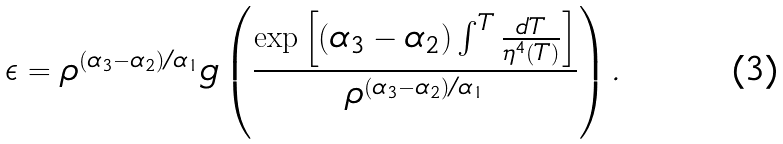<formula> <loc_0><loc_0><loc_500><loc_500>\epsilon = \rho ^ { ( \alpha _ { 3 } - \alpha _ { 2 } ) / \alpha _ { 1 } } g \left ( \frac { \exp \left [ ( \alpha _ { 3 } - \alpha _ { 2 } ) \int ^ { T } \frac { d T } { \eta ^ { 4 } ( T ) } \right ] } { \rho ^ { ( \alpha _ { 3 } - \alpha _ { 2 } ) / \alpha _ { 1 } } } \right ) .</formula> 